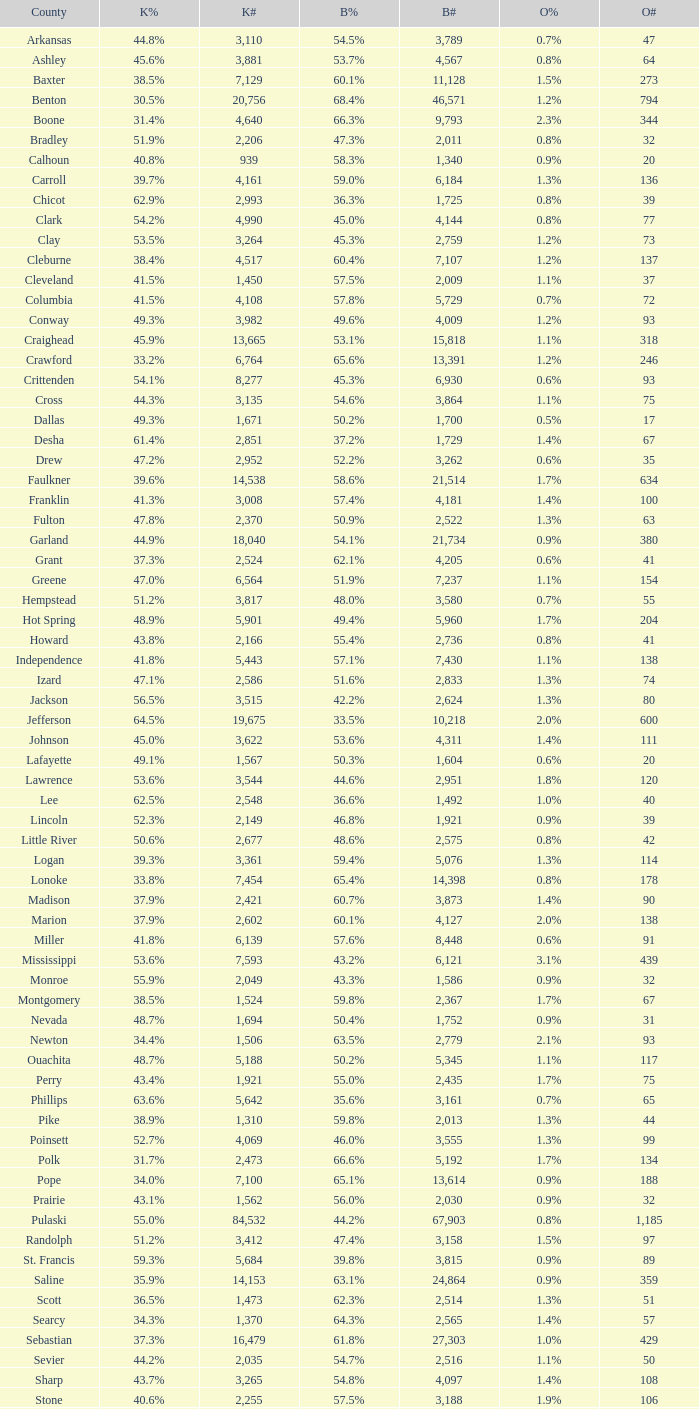What is the lowest Kerry#, when Others# is "106", and when Bush# is less than 3,188? None. 